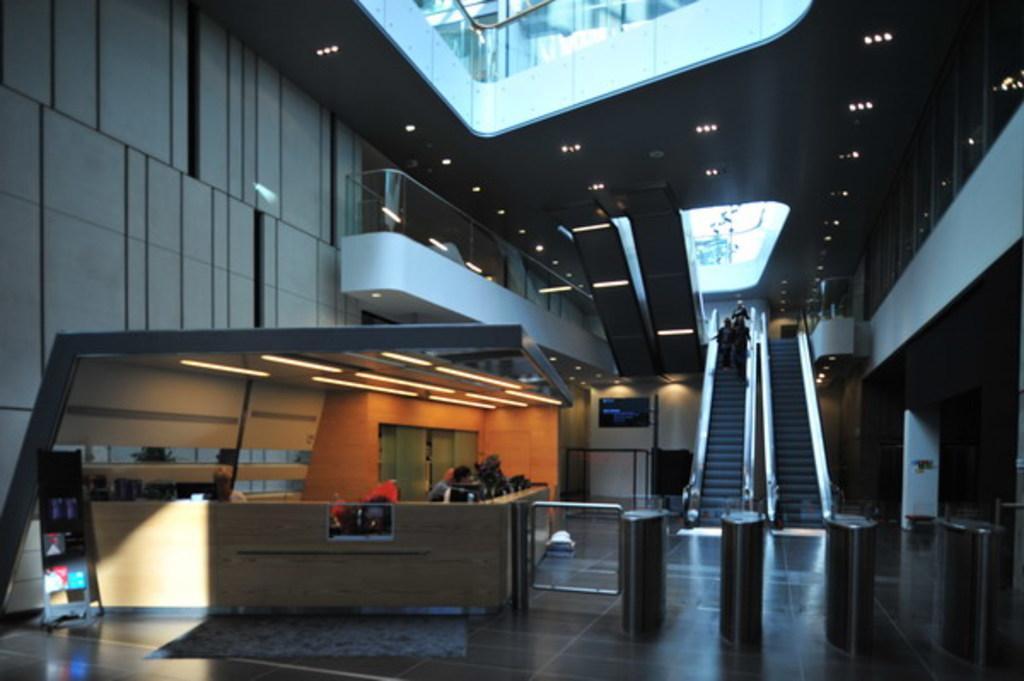In one or two sentences, can you explain what this image depicts? In this picture we can see some people standing on the escalator and some people at reception and in the background we can see lights and this is an inside view of a building. 